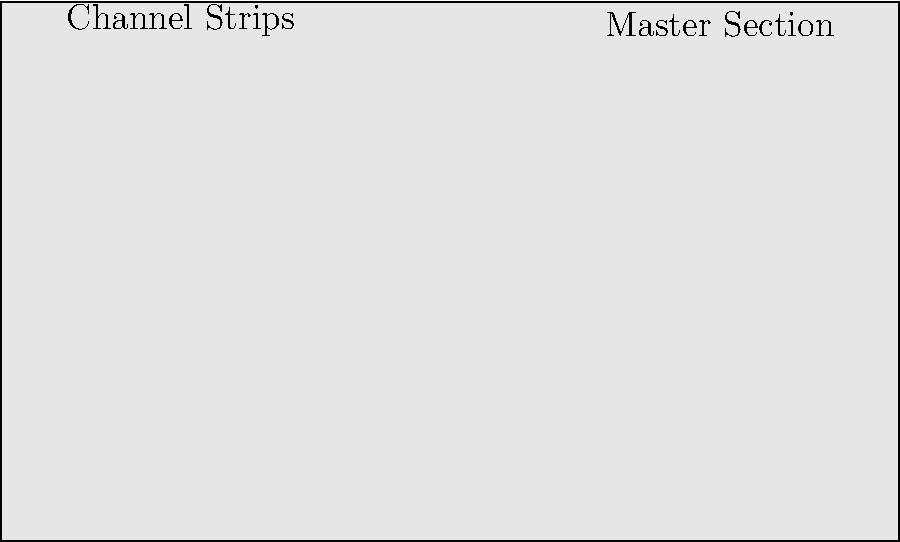As a singer-songwriter preparing for a live performance, you're familiarizing yourself with the mixing console layout. Which component of the channel strip is typically used to adjust the overall volume of individual channels, and how does its placement on the console facilitate quick adjustments during a live show? To answer this question, let's break down the components of a typical mixing console channel strip and their functions:

1. Channel strips are vertical sections on a mixing console, each representing an input channel.

2. The main components of a channel strip usually include (from top to bottom):
   a) Gain control
   b) EQ (Equalization) section
   c) Auxiliary sends
   d) Pan control
   e) Fader

3. The fader is the component used to adjust the overall volume of individual channels. It's typically a sliding control located at the bottom of each channel strip.

4. Faders are placed at the bottom of the console for several reasons:
   a) Easy access: This placement allows for quick adjustments during live performances.
   b) Ergonomics: It's more comfortable for the sound engineer to move their hands horizontally across the bottom of the console.
   c) Visual reference: The position of the faders gives a quick visual indication of relative volumes across all channels.

5. During a live show, the ability to make quick volume adjustments is crucial. The faders' placement allows the sound engineer or performer to:
   a) Easily locate and adjust specific channels
   b) Make multiple adjustments simultaneously using both hands
   c) Maintain a consistent mixing position while focusing on the stage or audience

6. The linear motion of faders also provides precise control over volume changes, allowing for smooth transitions and balance between different instruments or vocals.

In the context of a singer-songwriter, understanding the function and placement of faders is essential for managing your own vocal levels and potentially adjusting the mix of accompanying instruments during a performance.
Answer: Faders, located at the bottom of channel strips for easy access and quick adjustments during live performances. 